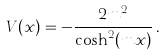Convert formula to latex. <formula><loc_0><loc_0><loc_500><loc_500>V ( x ) = - \frac { 2 m ^ { 2 } } { \cosh ^ { 2 } ( m x ) } \, .</formula> 